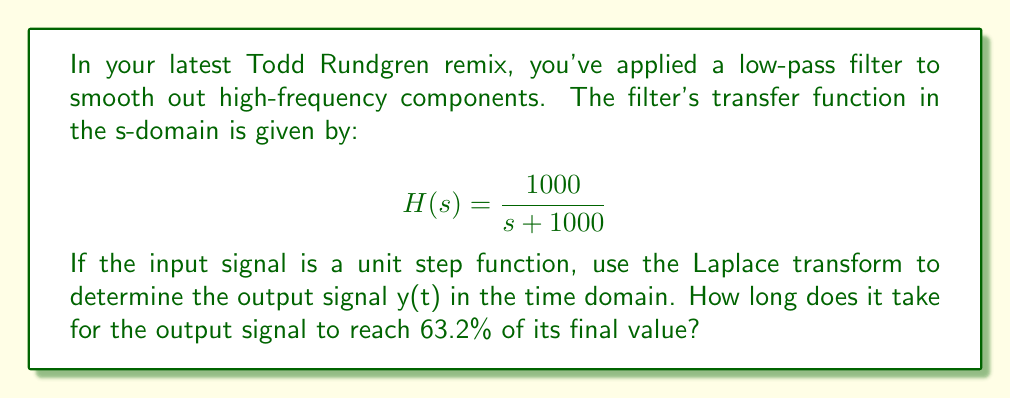Provide a solution to this math problem. To solve this problem, we'll follow these steps:

1) The Laplace transform of the unit step function u(t) is:
   $$\mathcal{L}\{u(t)\} = \frac{1}{s}$$

2) The output Y(s) in the s-domain is the product of the input and the transfer function:
   $$Y(s) = H(s) \cdot \frac{1}{s} = \frac{1000}{s(s + 1000)}$$

3) To find y(t), we need to perform inverse Laplace transform on Y(s):
   $$Y(s) = \frac{1000}{s(s + 1000)} = \frac{1}{s} - \frac{1}{s + 1000}$$

4) The inverse Laplace transform of this expression is:
   $$y(t) = 1 - e^{-1000t}$$

5) The final value of y(t) as t approaches infinity is 1.

6) To find when y(t) reaches 63.2% of its final value:
   $$0.632 = 1 - e^{-1000t}$$
   $$e^{-1000t} = 0.368$$
   $$-1000t = \ln(0.368)$$
   $$t = -\frac{\ln(0.368)}{1000} = 0.001\text{ seconds}$$

This time constant (0.001 seconds or 1 millisecond) is characteristic of the filter's cutoff frequency of 1000 rad/s, which is about 159 Hz. This low-pass filter will smooth out frequencies much higher than 159 Hz in your Todd Rundgren remix, potentially reducing harshness while preserving the fundamental frequencies of most instruments.
Answer: The output signal y(t) is $y(t) = 1 - e^{-1000t}$, and it takes 0.001 seconds (1 millisecond) to reach 63.2% of its final value. 